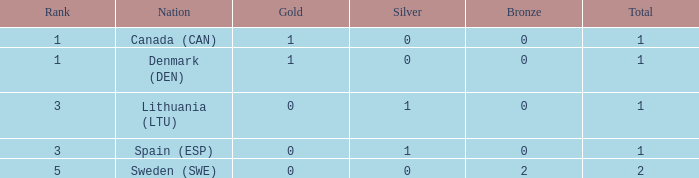What is the number of gold medals for Lithuania (ltu), when the total is more than 1? None. 